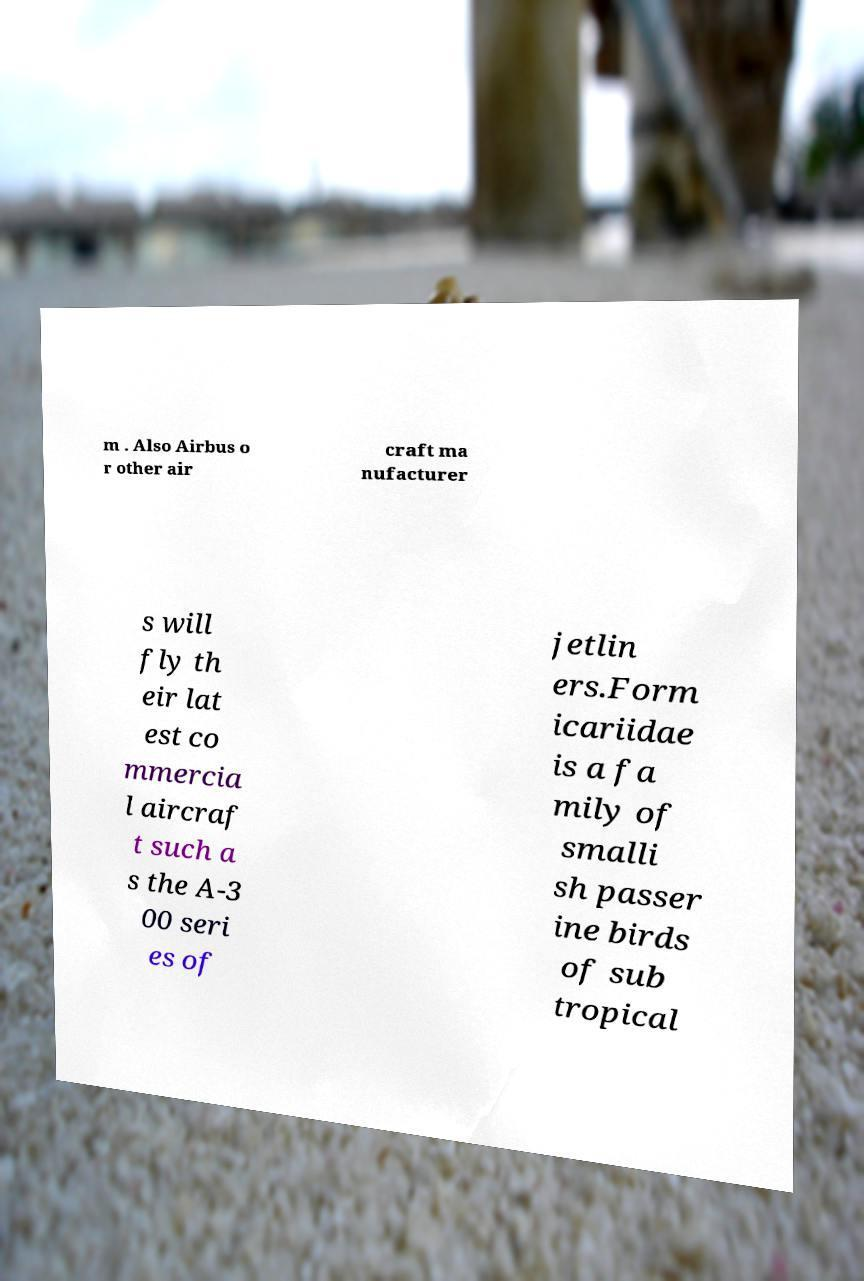I need the written content from this picture converted into text. Can you do that? m . Also Airbus o r other air craft ma nufacturer s will fly th eir lat est co mmercia l aircraf t such a s the A-3 00 seri es of jetlin ers.Form icariidae is a fa mily of smalli sh passer ine birds of sub tropical 